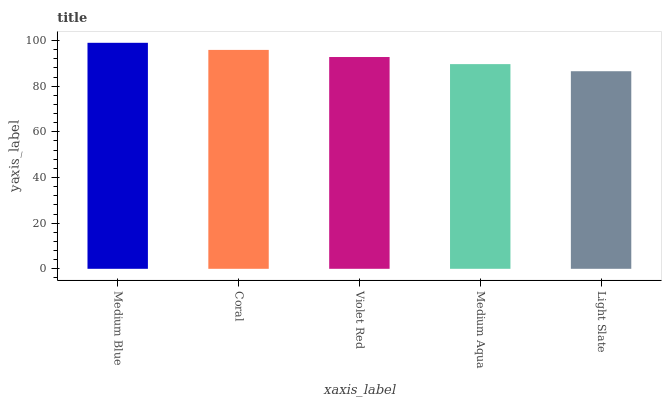Is Coral the minimum?
Answer yes or no. No. Is Coral the maximum?
Answer yes or no. No. Is Medium Blue greater than Coral?
Answer yes or no. Yes. Is Coral less than Medium Blue?
Answer yes or no. Yes. Is Coral greater than Medium Blue?
Answer yes or no. No. Is Medium Blue less than Coral?
Answer yes or no. No. Is Violet Red the high median?
Answer yes or no. Yes. Is Violet Red the low median?
Answer yes or no. Yes. Is Medium Blue the high median?
Answer yes or no. No. Is Coral the low median?
Answer yes or no. No. 